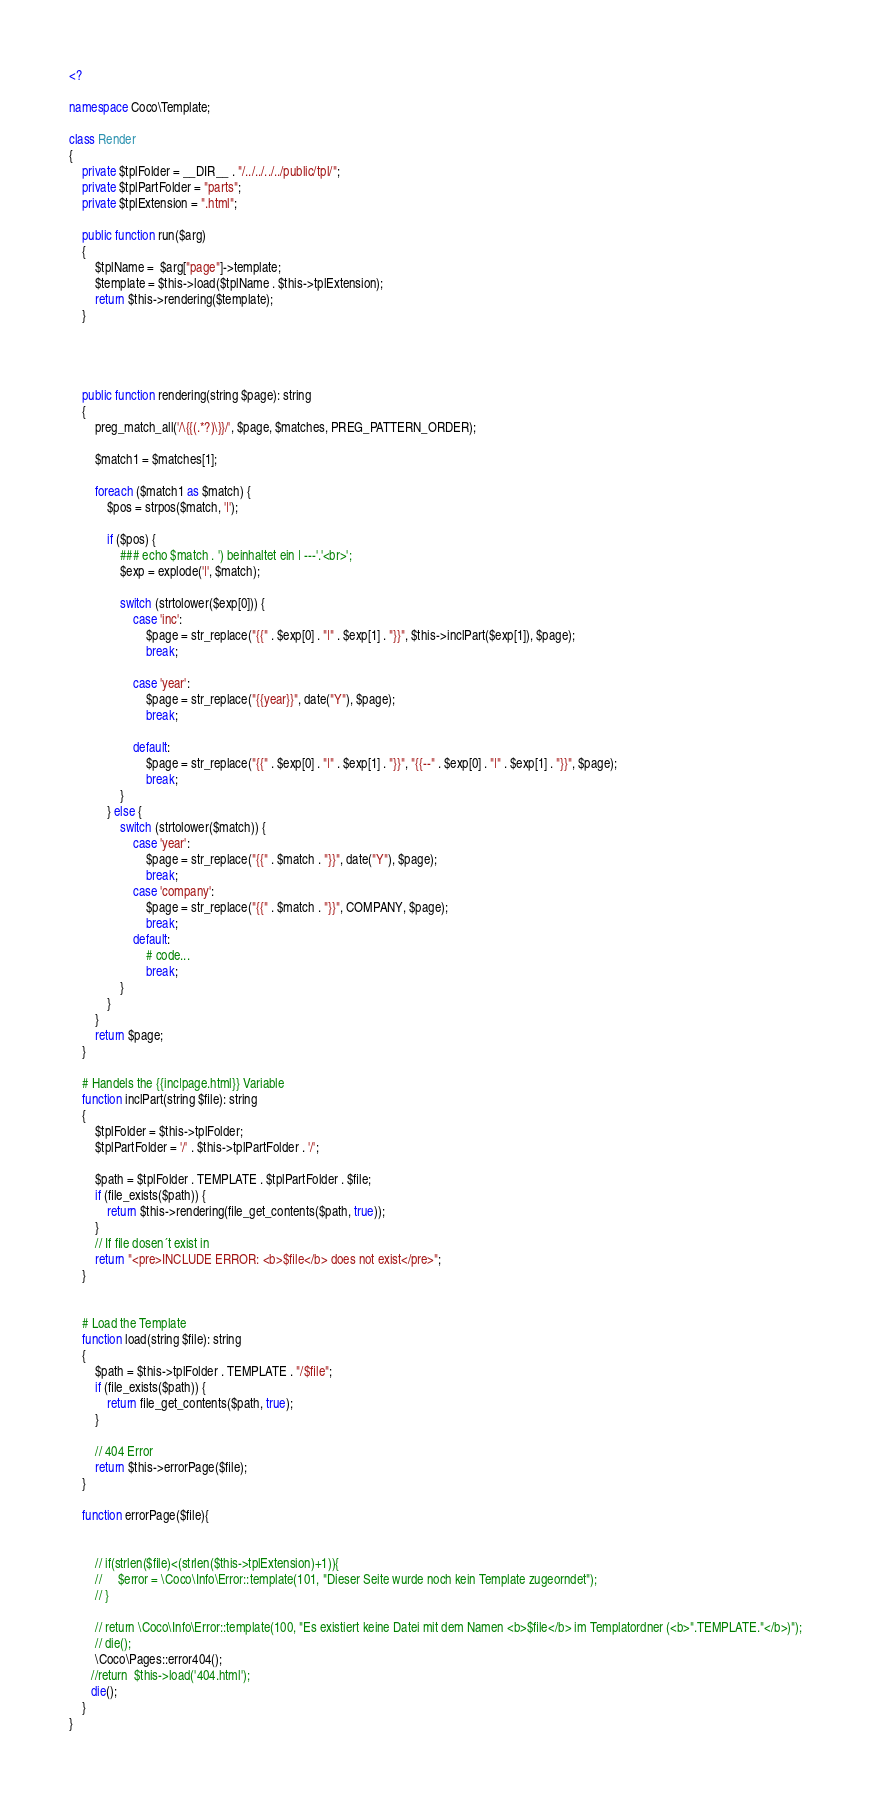Convert code to text. <code><loc_0><loc_0><loc_500><loc_500><_PHP_><?

namespace Coco\Template;

class Render
{
    private $tplFolder = __DIR__ . "/../../../../public/tpl/";
    private $tplPartFolder = "parts";
    private $tplExtension = ".html";

    public function run($arg)
    {
        $tplName =  $arg["page"]->template;
        $template = $this->load($tplName . $this->tplExtension);
        return $this->rendering($template);
    }




    public function rendering(string $page): string
    {
        preg_match_all('/\{{(.*?)\}}/', $page, $matches, PREG_PATTERN_ORDER);

        $match1 = $matches[1];

        foreach ($match1 as $match) {
            $pos = strpos($match, '|');

            if ($pos) {
                ### echo $match . ') beinhaltet ein | ---'.'<br>';
                $exp = explode('|', $match);

                switch (strtolower($exp[0])) {
                    case 'inc':
                        $page = str_replace("{{" . $exp[0] . "|" . $exp[1] . "}}", $this->inclPart($exp[1]), $page);
                        break;

                    case 'year':
                        $page = str_replace("{{year}}", date("Y"), $page);
                        break;

                    default:
                        $page = str_replace("{{" . $exp[0] . "|" . $exp[1] . "}}", "{{--" . $exp[0] . "|" . $exp[1] . "}}", $page);
                        break;
                }
            } else {
                switch (strtolower($match)) {
                    case 'year':
                        $page = str_replace("{{" . $match . "}}", date("Y"), $page);
                        break;
                    case 'company':
                        $page = str_replace("{{" . $match . "}}", COMPANY, $page);
                        break;
                    default:
                        # code...
                        break;
                }
            }
        }
        return $page;
    }

    # Handels the {{inc|page.html}} Variable
    function inclPart(string $file): string
    {
        $tplFolder = $this->tplFolder;
        $tplPartFolder = '/' . $this->tplPartFolder . '/';

        $path = $tplFolder . TEMPLATE . $tplPartFolder . $file;
        if (file_exists($path)) {
            return $this->rendering(file_get_contents($path, true));
        }
        // If file dosen´t exist in 
        return "<pre>INCLUDE ERROR: <b>$file</b> does not exist</pre>";
    }


    # Load the Template
    function load(string $file): string
    {
        $path = $this->tplFolder . TEMPLATE . "/$file";
        if (file_exists($path)) {
            return file_get_contents($path, true);
        }

        // 404 Error
        return $this->errorPage($file);
    }

    function errorPage($file){


        // if(strlen($file)<(strlen($this->tplExtension)+1)){
        //     $error = \Coco\Info\Error::template(101, "Dieser Seite wurde noch kein Template zugeorndet");
        // }

        // return \Coco\Info\Error::template(100, "Es existiert keine Datei mit dem Namen <b>$file</b> im Templatordner (<b>".TEMPLATE."</b>)");
        // die();
        \Coco\Pages::error404();
       //return  $this->load('404.html');
       die();
    }
}
</code> 